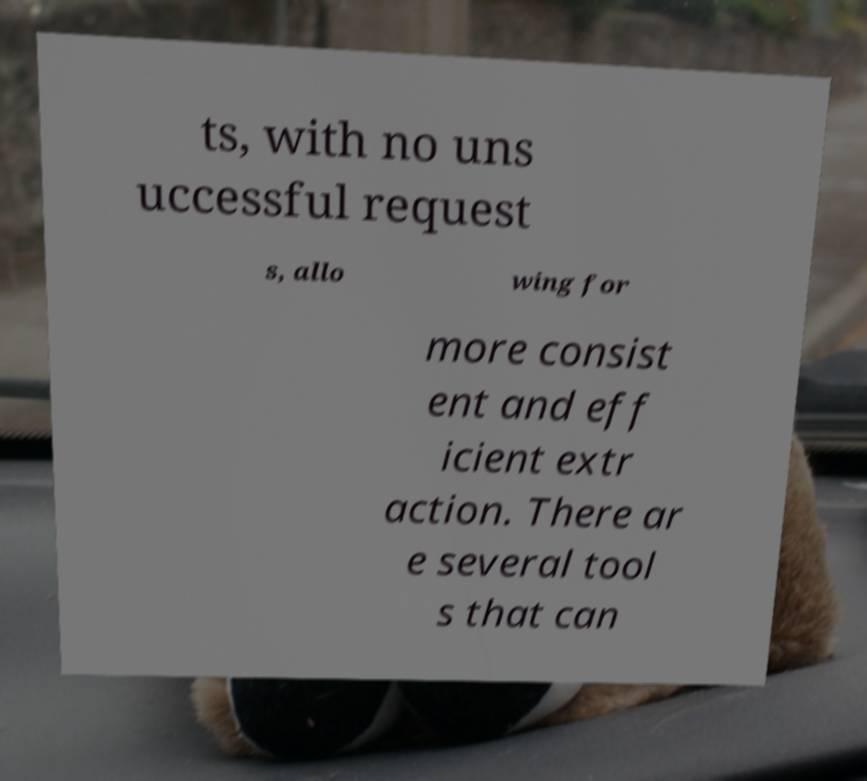Could you assist in decoding the text presented in this image and type it out clearly? ts, with no uns uccessful request s, allo wing for more consist ent and eff icient extr action. There ar e several tool s that can 